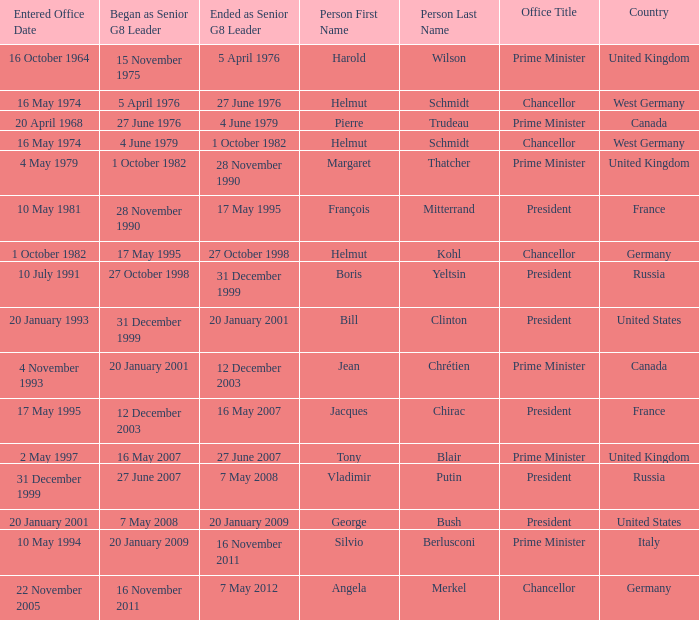When did Jacques Chirac stop being a G8 leader? 16 May 2007. 